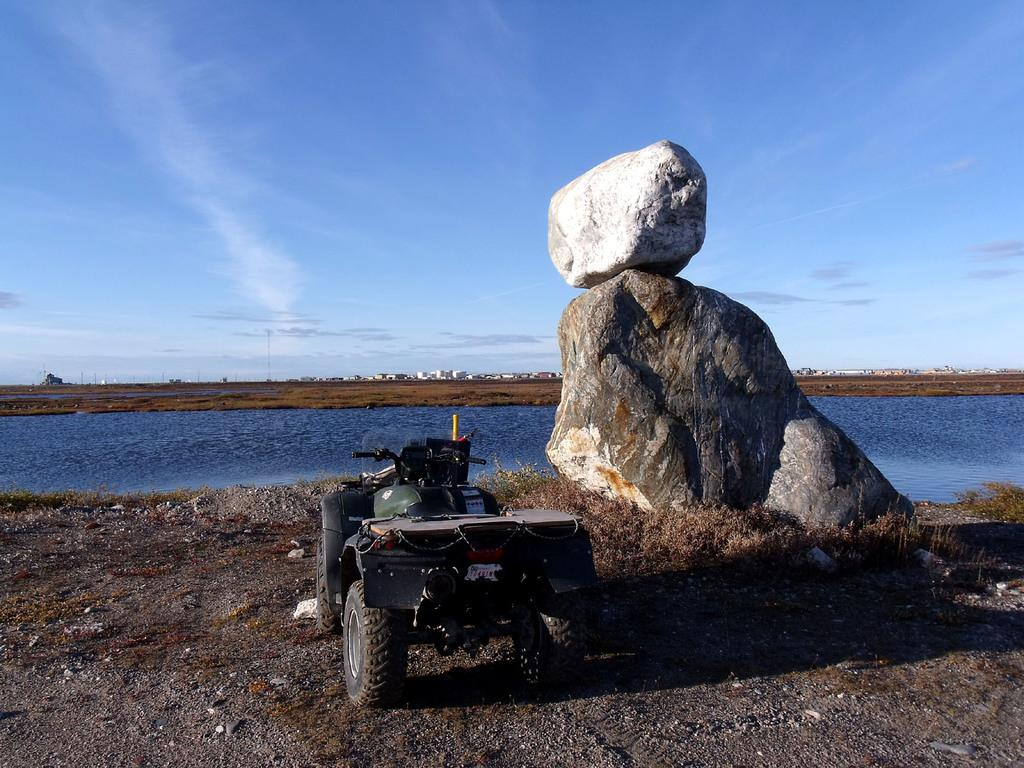What is located at the bottom of the image? There is a vehicle at the bottom of the image. What can be seen on the ground in the image? Rocks are present on the ground. What is visible in the background of the image? There is water, buildings, and poles visible in the background of the image. What is visible in the sky in the image? Clouds are visible in the sky. What type of lettuce is growing in the image? There is no lettuce present in the image. What design is featured on the vehicle in the image? The provided facts do not mention any specific design on the vehicle, so we cannot answer this question. 